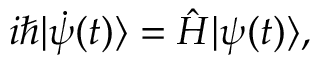Convert formula to latex. <formula><loc_0><loc_0><loc_500><loc_500>i \hbar { | } \dot { \psi } ( t ) \rangle = \hat { H } | \psi ( t ) \rangle ,</formula> 